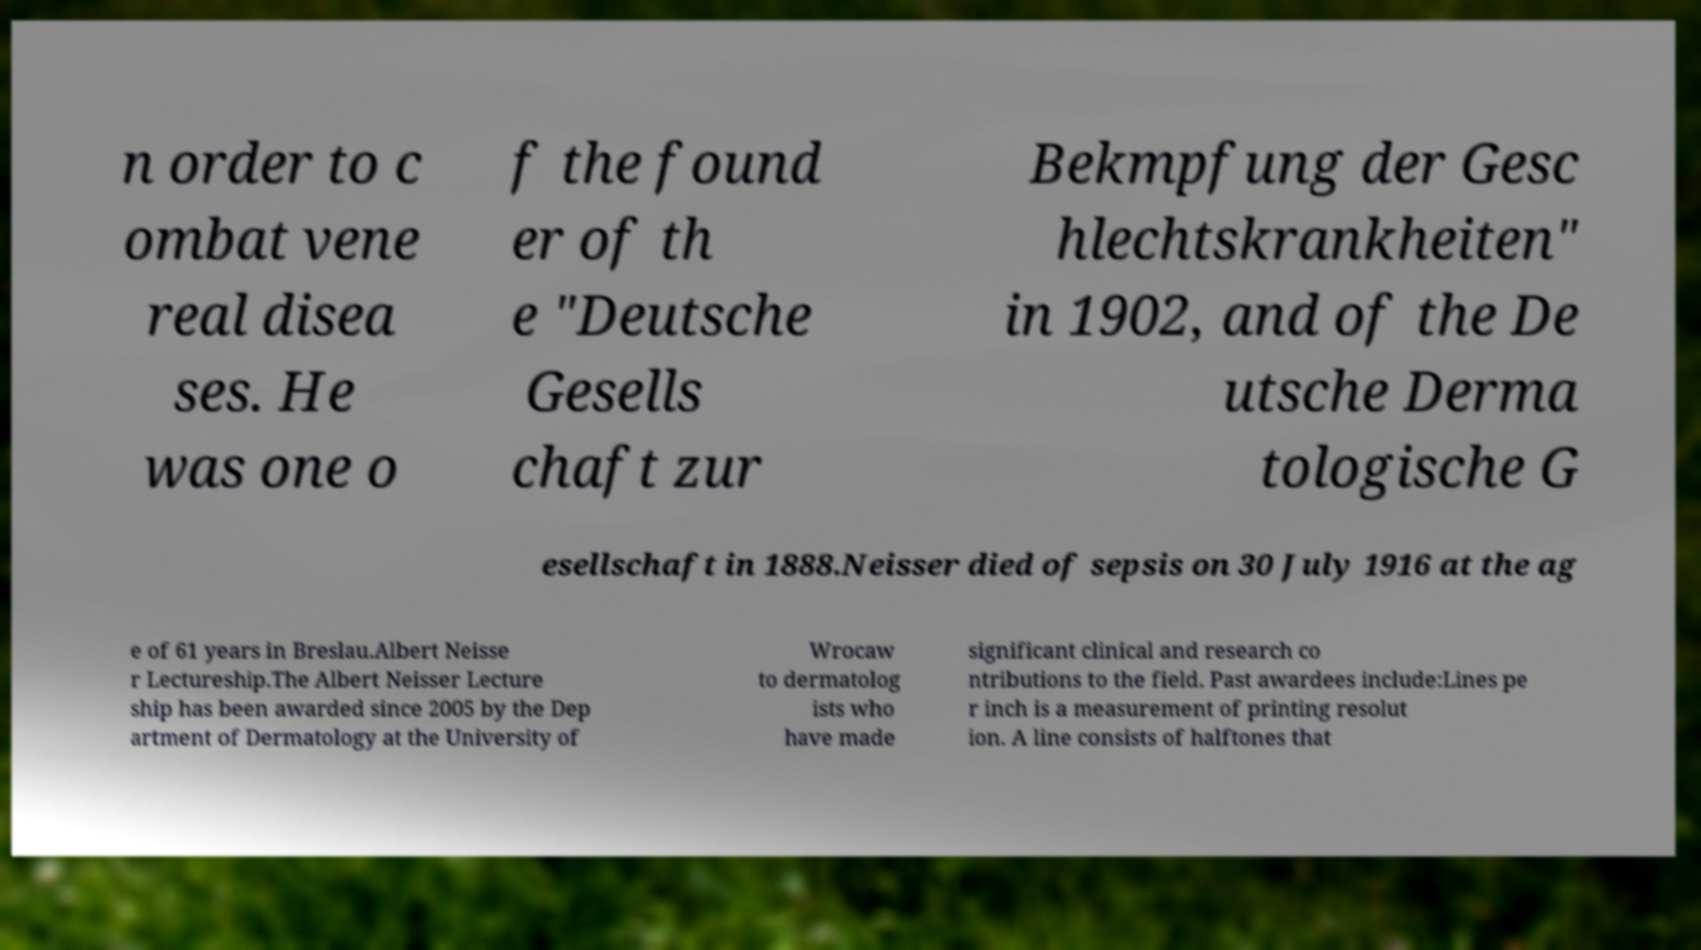What messages or text are displayed in this image? I need them in a readable, typed format. n order to c ombat vene real disea ses. He was one o f the found er of th e "Deutsche Gesells chaft zur Bekmpfung der Gesc hlechtskrankheiten" in 1902, and of the De utsche Derma tologische G esellschaft in 1888.Neisser died of sepsis on 30 July 1916 at the ag e of 61 years in Breslau.Albert Neisse r Lectureship.The Albert Neisser Lecture ship has been awarded since 2005 by the Dep artment of Dermatology at the University of Wrocaw to dermatolog ists who have made significant clinical and research co ntributions to the field. Past awardees include:Lines pe r inch is a measurement of printing resolut ion. A line consists of halftones that 